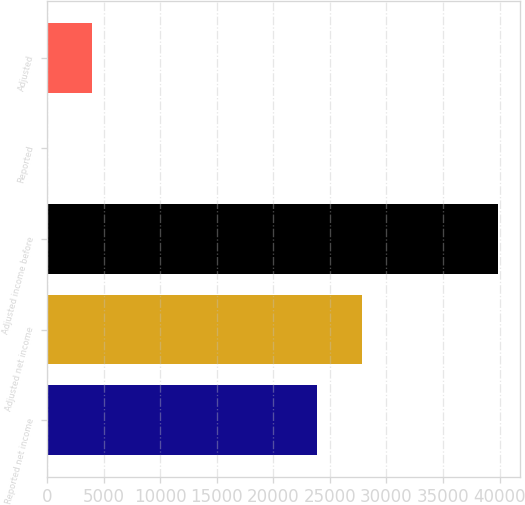<chart> <loc_0><loc_0><loc_500><loc_500><bar_chart><fcel>Reported net income<fcel>Adjusted net income<fcel>Adjusted income before<fcel>Reported<fcel>Adjusted<nl><fcel>23840<fcel>27823.8<fcel>39839<fcel>1.09<fcel>3984.88<nl></chart> 